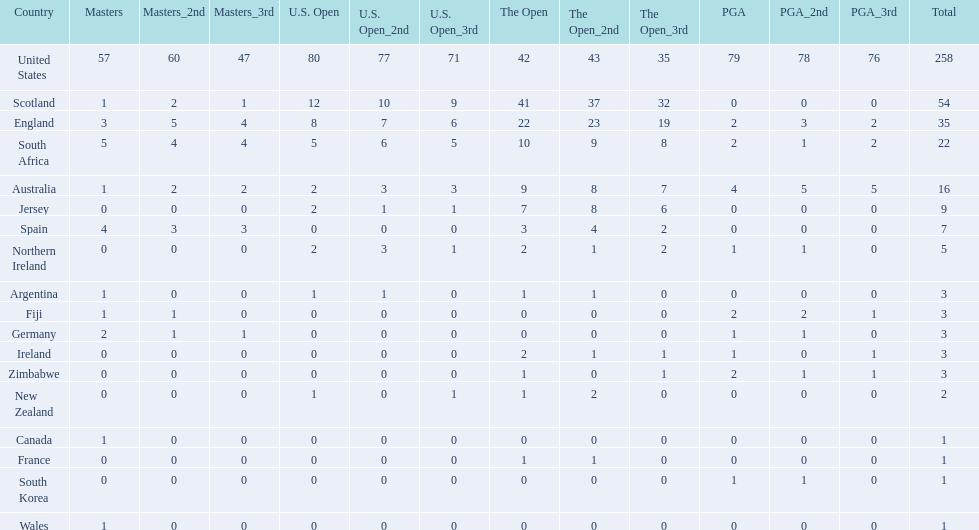How many u.s. open wins does fiji have? 0. 